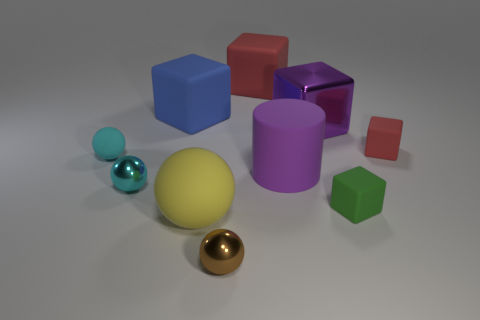There is another ball that is the same color as the small matte ball; what size is it?
Provide a short and direct response. Small. Are there any other things that are the same color as the big rubber ball?
Provide a short and direct response. No. Is the color of the ball behind the big purple rubber cylinder the same as the large cylinder?
Provide a short and direct response. No. What material is the small thing on the right side of the small green matte object?
Your response must be concise. Rubber. How many other big objects are the same shape as the large shiny object?
Your answer should be compact. 2. What material is the block on the left side of the small sphere in front of the large rubber sphere?
Keep it short and to the point. Rubber. There is a small metal thing that is the same color as the small matte ball; what shape is it?
Offer a very short reply. Sphere. Are there any large things made of the same material as the purple cylinder?
Your answer should be very brief. Yes. What shape is the tiny green object?
Your answer should be very brief. Cube. What number of large green rubber cylinders are there?
Give a very brief answer. 0. 